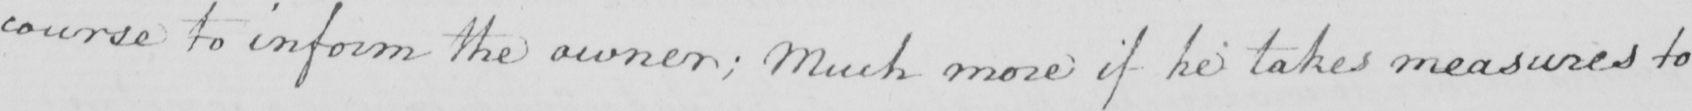Please transcribe the handwritten text in this image. course to inform the owner ; much more if he takes measures to 